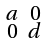Convert formula to latex. <formula><loc_0><loc_0><loc_500><loc_500>\begin{smallmatrix} a & 0 \\ 0 & d \end{smallmatrix}</formula> 